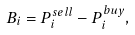<formula> <loc_0><loc_0><loc_500><loc_500>B _ { i } = P _ { i } ^ { s e l l } - P _ { i } ^ { b u y } ,</formula> 